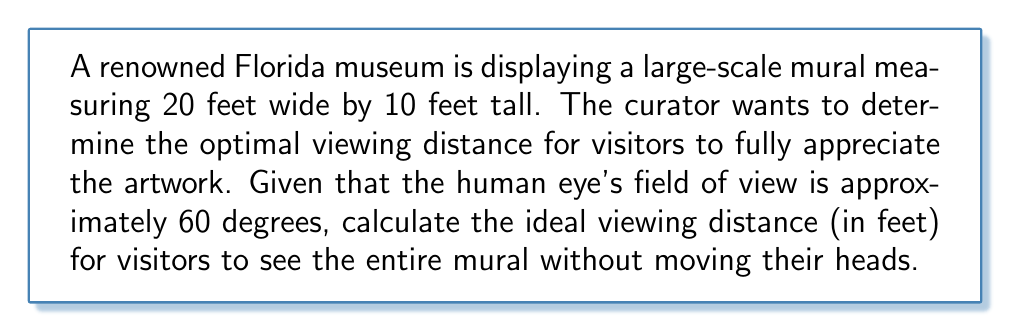Show me your answer to this math problem. To solve this problem, we need to consider the geometry of the viewer's perspective and the mural's dimensions. Let's approach this step-by-step:

1. We know that the human eye's field of view is approximately 60 degrees. This means that the mural should fit within this angle for optimal viewing.

2. We can use the tangent function to relate the mural's dimensions to the viewing distance. The tangent of half the viewing angle (30 degrees) will be equal to half the mural's width divided by the viewing distance.

3. Let's define our variables:
   $w$ = width of the mural = 20 feet
   $d$ = optimal viewing distance (what we're solving for)

4. We can set up the equation:

   $$\tan(30°) = \frac{w/2}{d}$$

5. We know that $\tan(30°) = \frac{1}{\sqrt{3}} \approx 0.5774$

6. Substituting the values:

   $$0.5774 = \frac{20/2}{d}$$
   $$0.5774 = \frac{10}{d}$$

7. Solving for $d$:

   $$d = \frac{10}{0.5774} \approx 17.32$$

8. Therefore, the optimal viewing distance is approximately 17.32 feet.

This calculation ensures that visitors can see the entire width of the mural within their field of view. It's worth noting that this calculation is based on the mural's width, as it's the larger dimension. The height of the mural (10 feet) will easily fit within the vertical field of view at this distance.
Answer: The optimal viewing distance for the 20-foot wide mural is approximately 17.32 feet. 